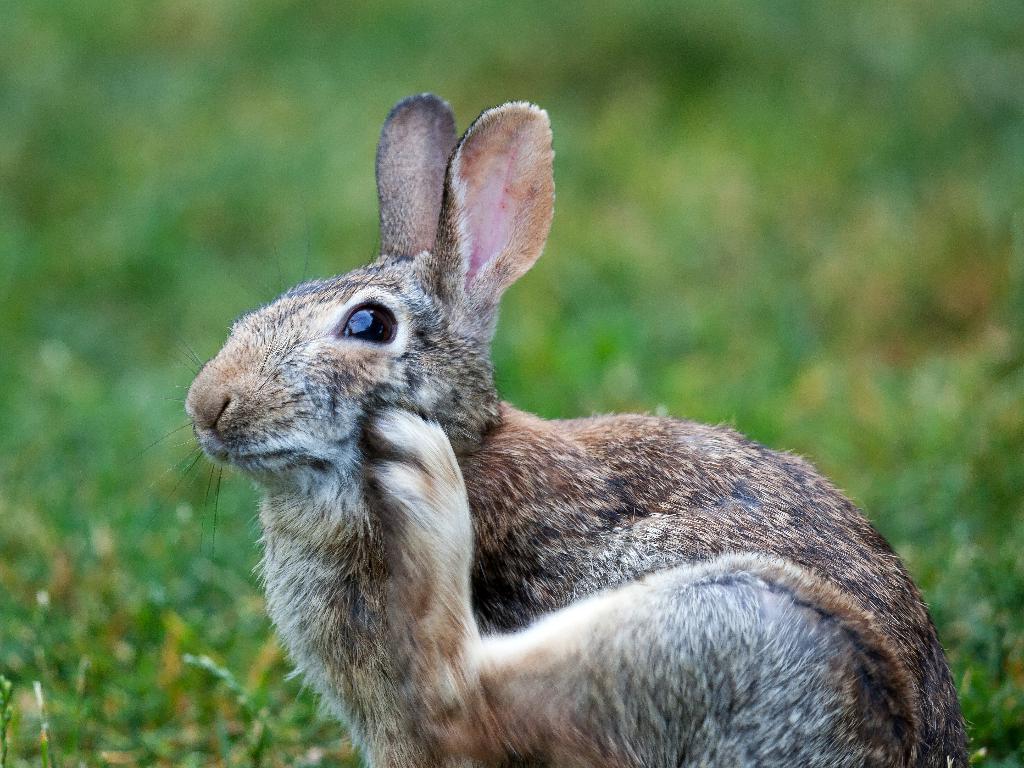How would you summarize this image in a sentence or two? In the picture there is a rabbit present on the grass. 